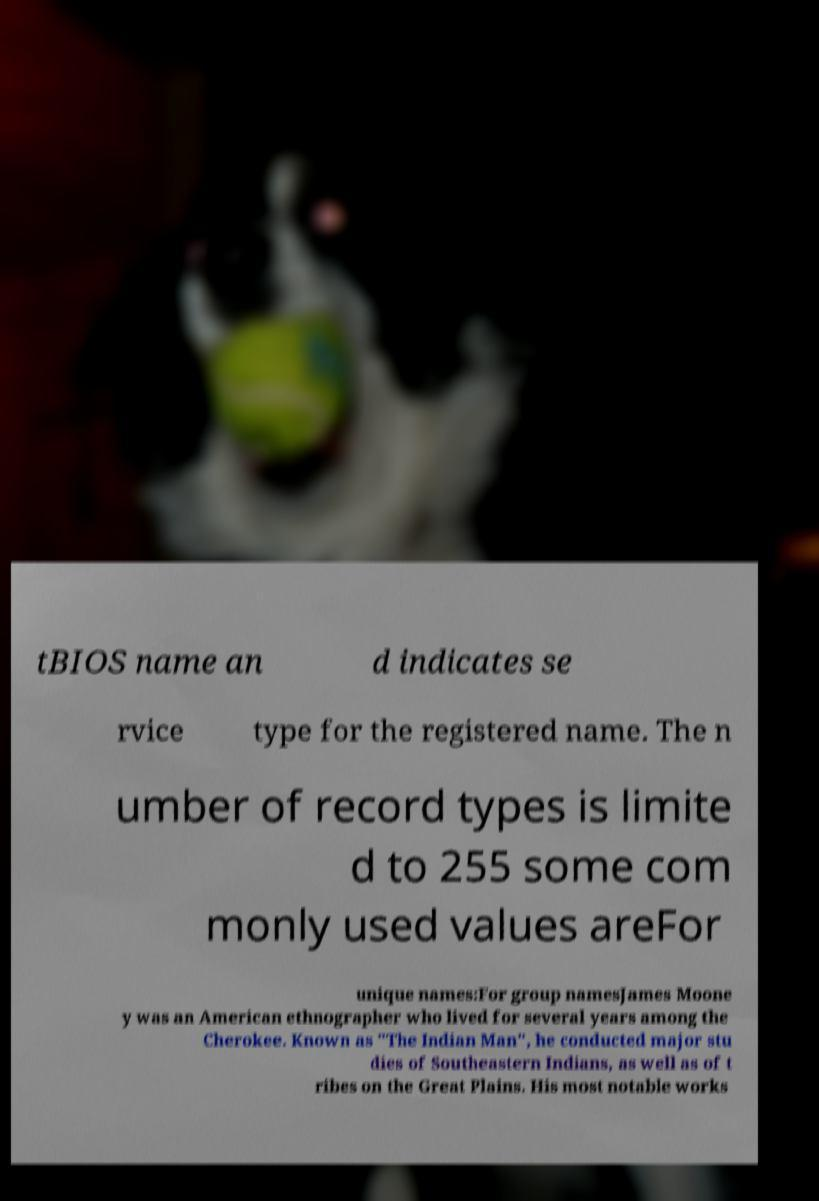Can you read and provide the text displayed in the image?This photo seems to have some interesting text. Can you extract and type it out for me? tBIOS name an d indicates se rvice type for the registered name. The n umber of record types is limite d to 255 some com monly used values areFor unique names:For group namesJames Moone y was an American ethnographer who lived for several years among the Cherokee. Known as "The Indian Man", he conducted major stu dies of Southeastern Indians, as well as of t ribes on the Great Plains. His most notable works 